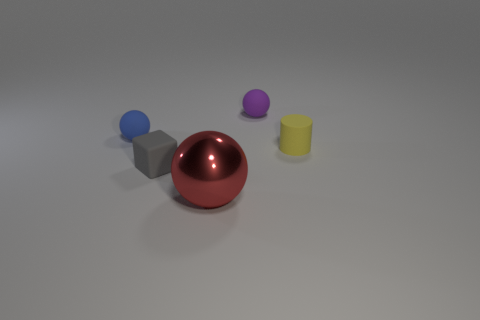Are there any other things that are the same material as the cube?
Keep it short and to the point. Yes. Are there the same number of gray objects to the left of the small gray rubber thing and small purple matte objects to the left of the red metal ball?
Offer a terse response. Yes. Is the material of the blue object the same as the block?
Ensure brevity in your answer.  Yes. What number of gray objects are tiny spheres or rubber blocks?
Your answer should be very brief. 1. How many purple rubber things are the same shape as the blue thing?
Your answer should be compact. 1. What material is the large red thing?
Give a very brief answer. Metal. Is the number of tiny cylinders that are left of the blue rubber object the same as the number of gray cubes?
Offer a terse response. No. What shape is the gray rubber thing that is the same size as the blue matte thing?
Provide a short and direct response. Cube. Are there any tiny purple spheres in front of the matte sphere on the right side of the tiny blue sphere?
Make the answer very short. No. What number of big objects are either blue shiny cylinders or metallic spheres?
Give a very brief answer. 1. 